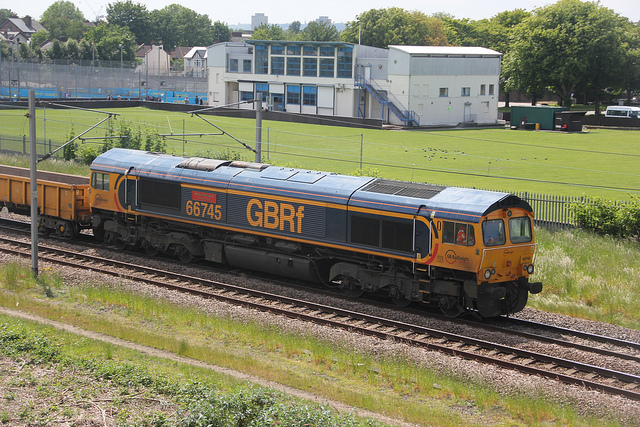<image>How many tracks on the ground? I am not sure how many tracks are on the ground. However, it appears there are two. How many tracks on the ground? I don't know how many tracks are on the ground. It seems there are 2 tracks. 